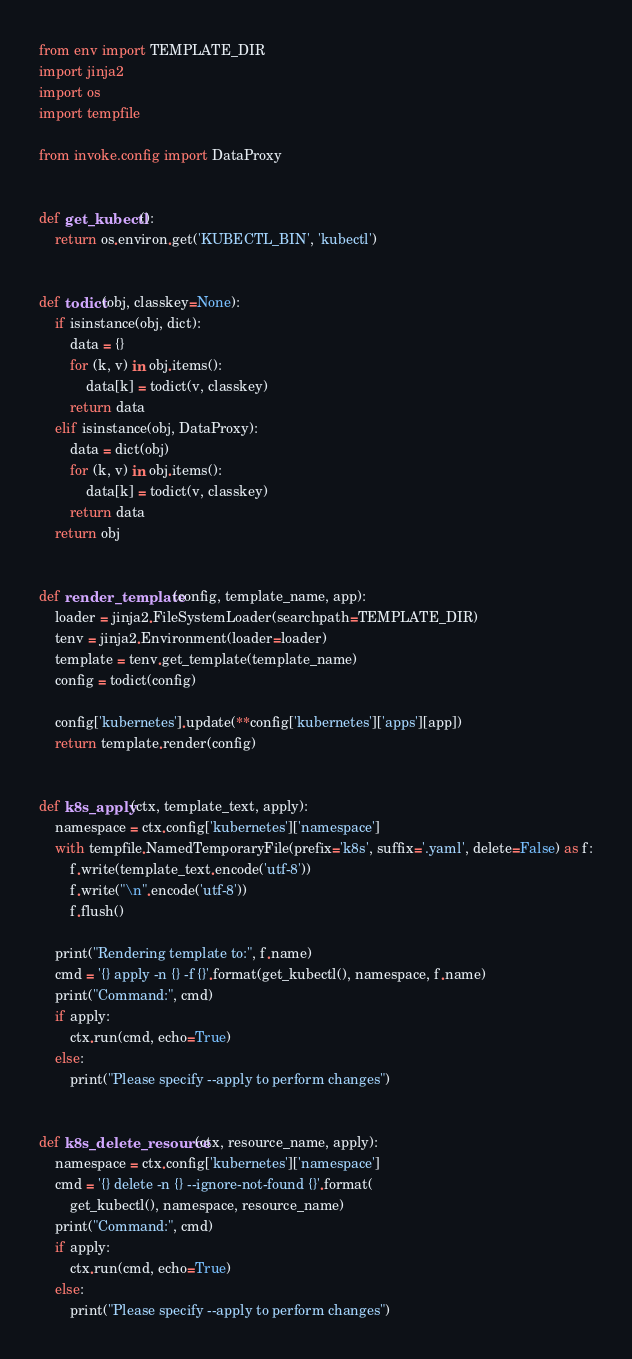<code> <loc_0><loc_0><loc_500><loc_500><_Python_>from env import TEMPLATE_DIR
import jinja2
import os
import tempfile

from invoke.config import DataProxy


def get_kubectl():
    return os.environ.get('KUBECTL_BIN', 'kubectl')


def todict(obj, classkey=None):
    if isinstance(obj, dict):
        data = {}
        for (k, v) in obj.items():
            data[k] = todict(v, classkey)
        return data
    elif isinstance(obj, DataProxy):
        data = dict(obj)
        for (k, v) in obj.items():
            data[k] = todict(v, classkey)
        return data
    return obj


def render_template(config, template_name, app):
    loader = jinja2.FileSystemLoader(searchpath=TEMPLATE_DIR)
    tenv = jinja2.Environment(loader=loader)
    template = tenv.get_template(template_name)
    config = todict(config)

    config['kubernetes'].update(**config['kubernetes']['apps'][app])
    return template.render(config)


def k8s_apply(ctx, template_text, apply):
    namespace = ctx.config['kubernetes']['namespace']
    with tempfile.NamedTemporaryFile(prefix='k8s', suffix='.yaml', delete=False) as f:
        f.write(template_text.encode('utf-8'))
        f.write("\n".encode('utf-8'))
        f.flush()

    print("Rendering template to:", f.name)
    cmd = '{} apply -n {} -f {}'.format(get_kubectl(), namespace, f.name)
    print("Command:", cmd)
    if apply:
        ctx.run(cmd, echo=True)
    else:
        print("Please specify --apply to perform changes")


def k8s_delete_resource(ctx, resource_name, apply):
    namespace = ctx.config['kubernetes']['namespace']
    cmd = '{} delete -n {} --ignore-not-found {}'.format(
        get_kubectl(), namespace, resource_name)
    print("Command:", cmd)
    if apply:
        ctx.run(cmd, echo=True)
    else:
        print("Please specify --apply to perform changes")
</code> 